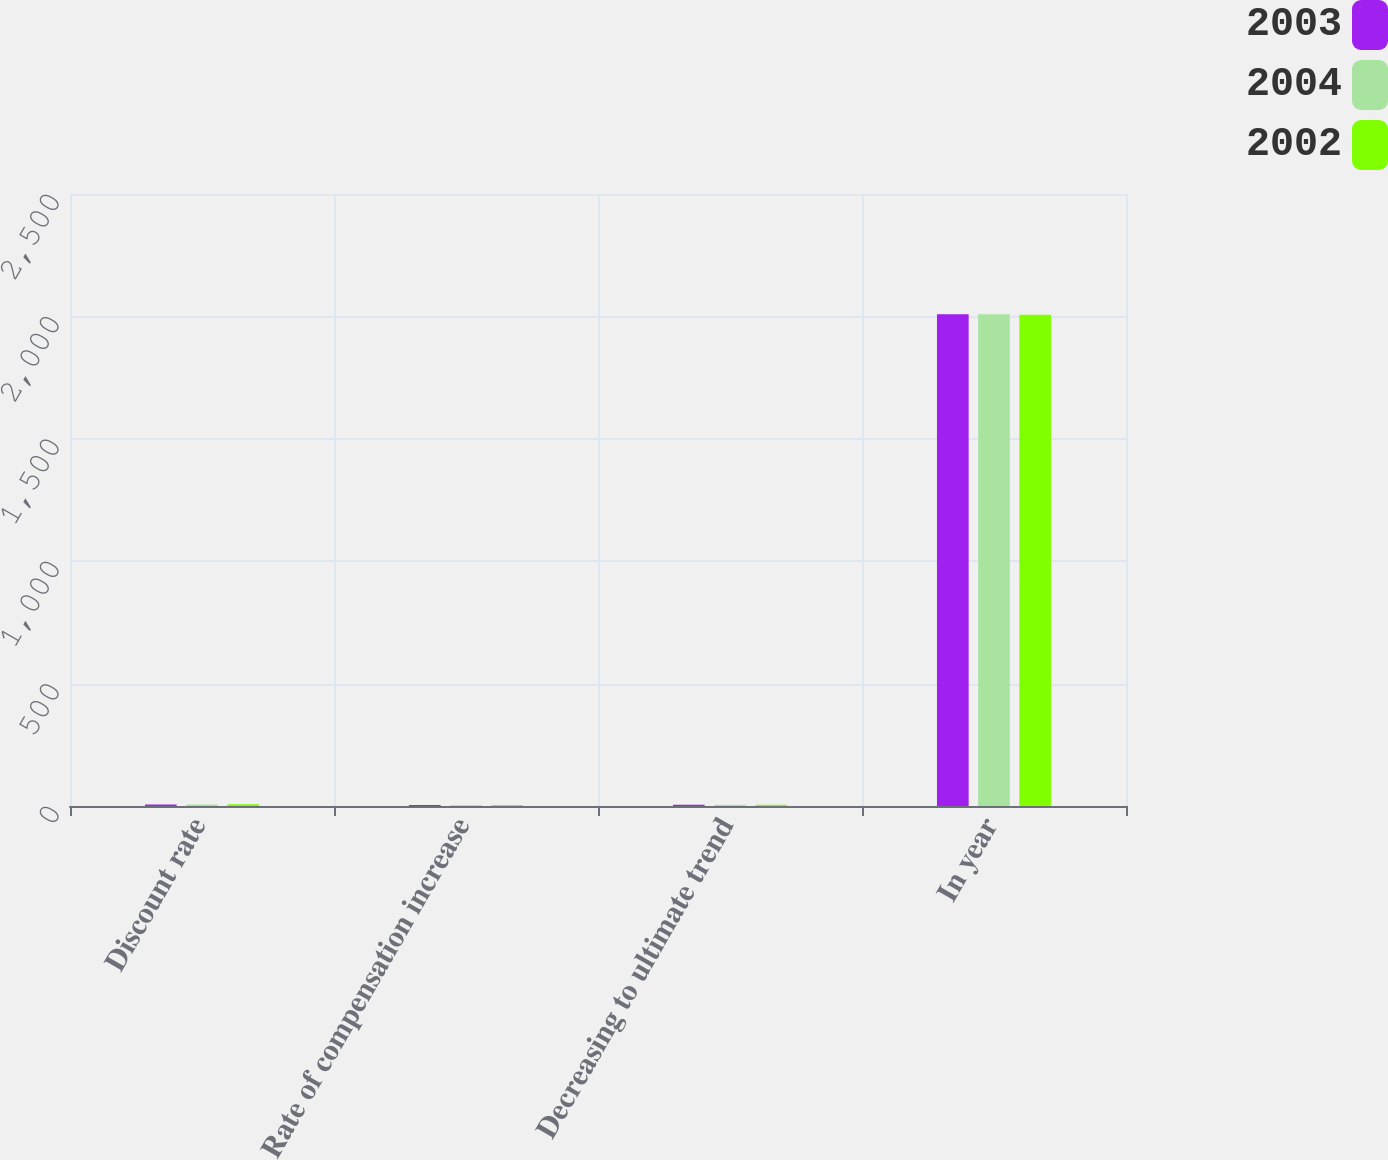Convert chart to OTSL. <chart><loc_0><loc_0><loc_500><loc_500><stacked_bar_chart><ecel><fcel>Discount rate<fcel>Rate of compensation increase<fcel>Decreasing to ultimate trend<fcel>In year<nl><fcel>2003<fcel>5.75<fcel>3.75<fcel>5<fcel>2009<nl><fcel>2004<fcel>6.25<fcel>3.75<fcel>5<fcel>2009<nl><fcel>2002<fcel>6.75<fcel>4<fcel>5.25<fcel>2007<nl></chart> 